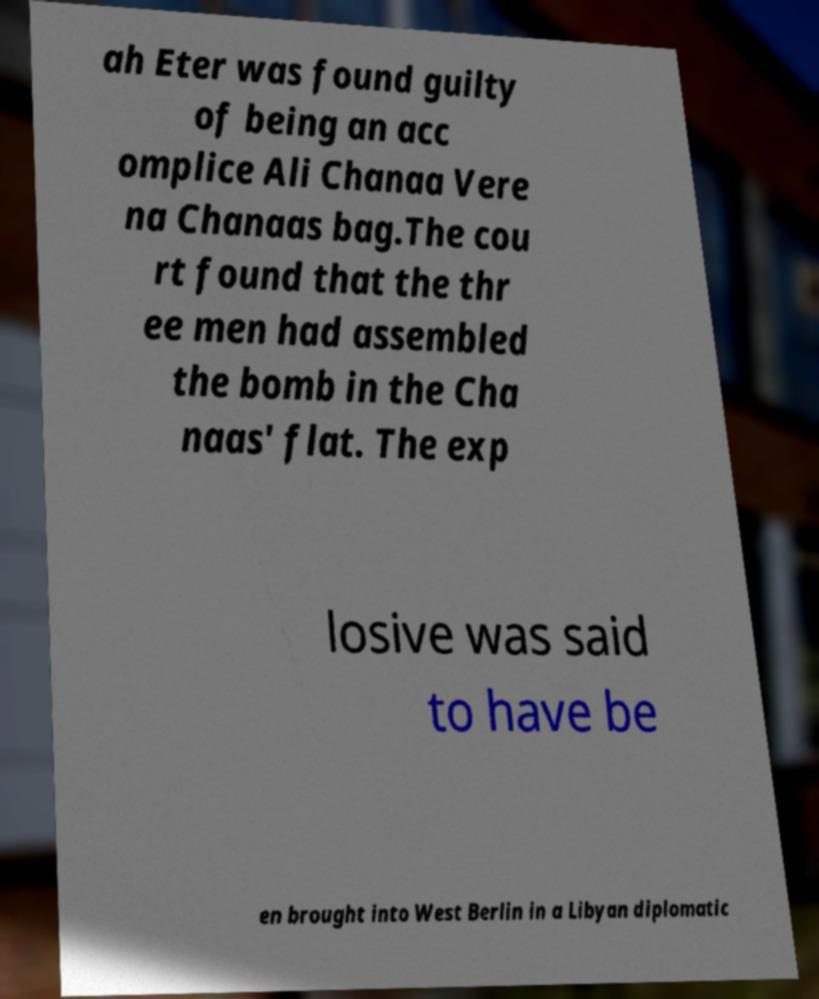Could you assist in decoding the text presented in this image and type it out clearly? ah Eter was found guilty of being an acc omplice Ali Chanaa Vere na Chanaas bag.The cou rt found that the thr ee men had assembled the bomb in the Cha naas' flat. The exp losive was said to have be en brought into West Berlin in a Libyan diplomatic 